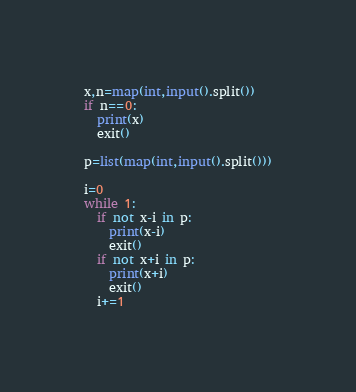<code> <loc_0><loc_0><loc_500><loc_500><_Python_>x,n=map(int,input().split())
if n==0:
  print(x)
  exit()

p=list(map(int,input().split()))

i=0
while 1:
  if not x-i in p:
    print(x-i)
    exit()
  if not x+i in p:
    print(x+i)
    exit()
  i+=1</code> 